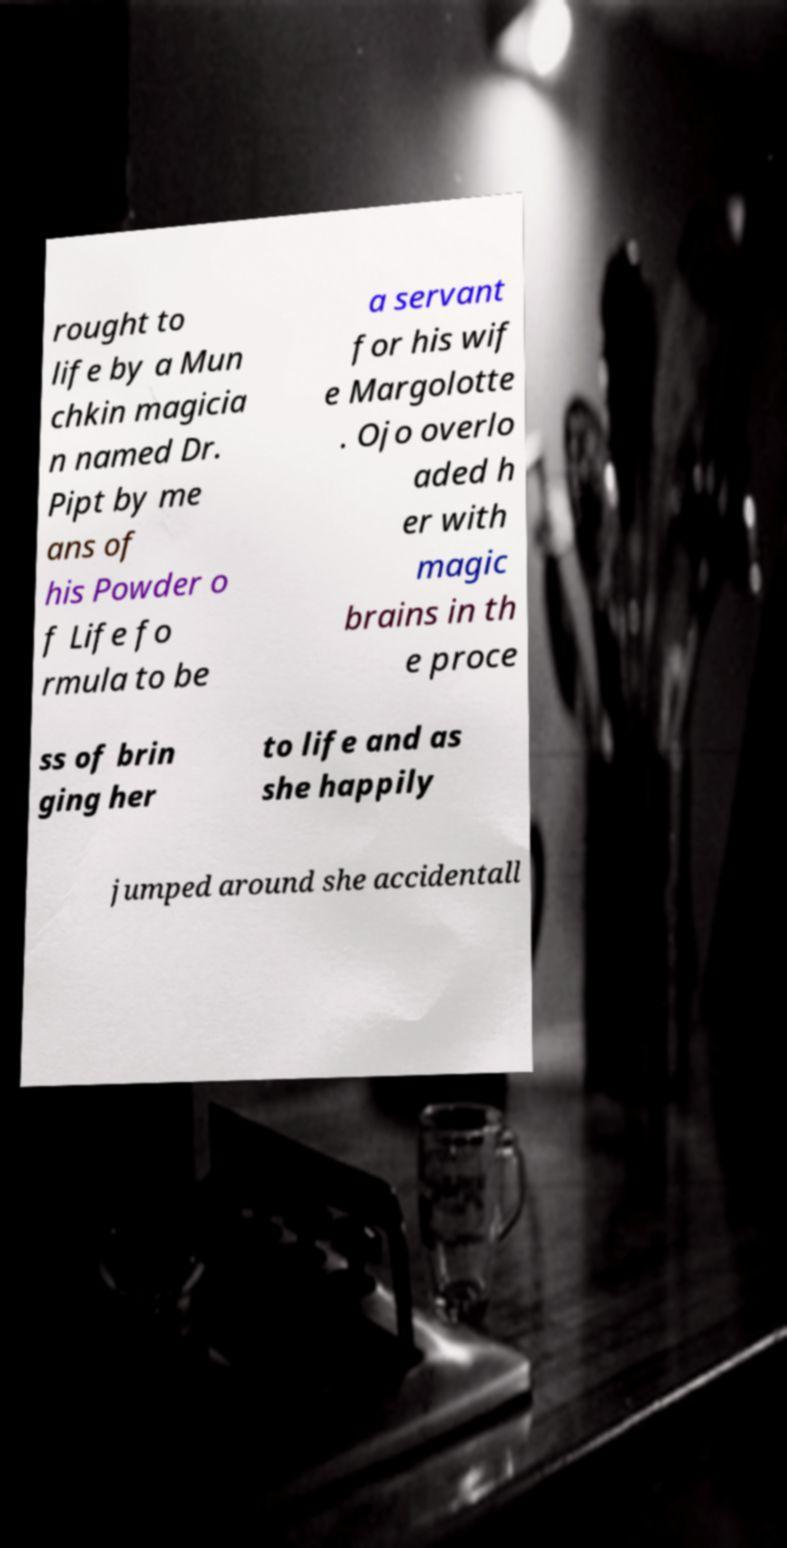What messages or text are displayed in this image? I need them in a readable, typed format. rought to life by a Mun chkin magicia n named Dr. Pipt by me ans of his Powder o f Life fo rmula to be a servant for his wif e Margolotte . Ojo overlo aded h er with magic brains in th e proce ss of brin ging her to life and as she happily jumped around she accidentall 